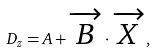Convert formula to latex. <formula><loc_0><loc_0><loc_500><loc_500>D _ { z } = A + \overrightarrow { B } \cdot \overrightarrow { X } ,</formula> 